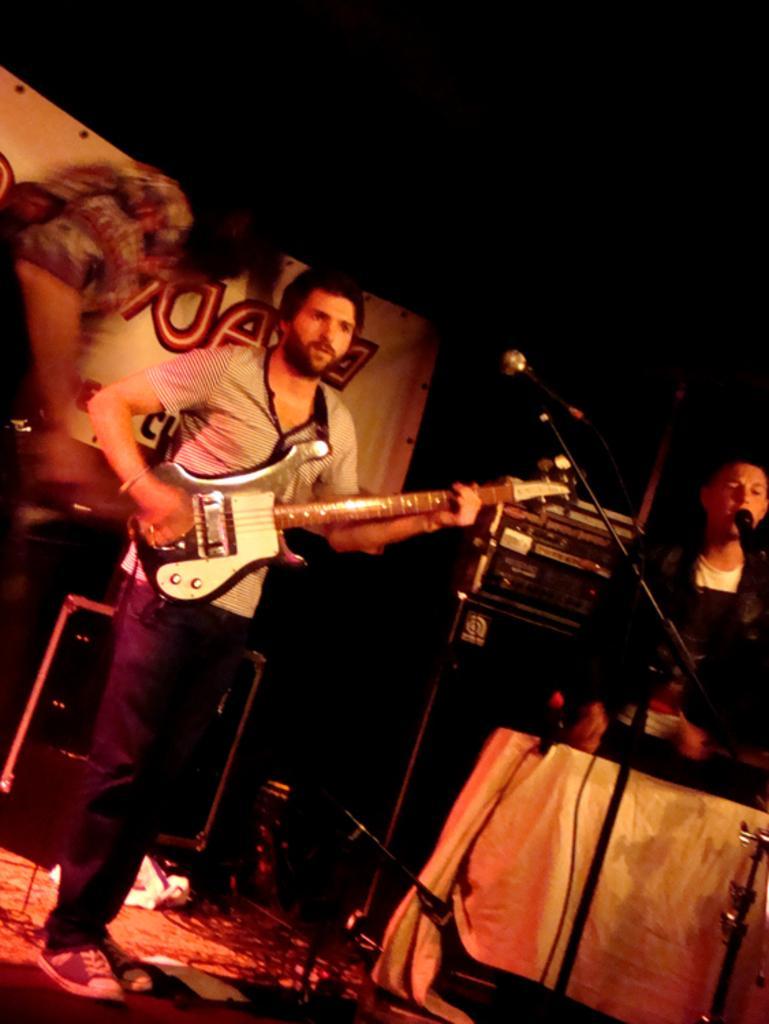How would you summarize this image in a sentence or two? This person is standing and playing a guitar. This person is singing in-front of a mic. This are electronic devices. A mic with mic holder. Banner in white color. 